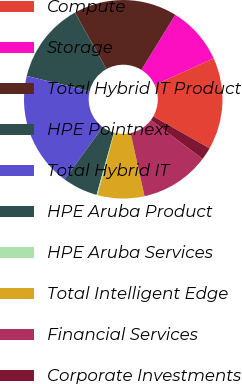Convert chart to OTSL. <chart><loc_0><loc_0><loc_500><loc_500><pie_chart><fcel>Compute<fcel>Storage<fcel>Total Hybrid IT Product<fcel>HPE Pointnext<fcel>Total Hybrid IT<fcel>HPE Aruba Product<fcel>HPE Aruba Services<fcel>Total Intelligent Edge<fcel>Financial Services<fcel>Corporate Investments<nl><fcel>15.0%<fcel>9.44%<fcel>16.86%<fcel>13.15%<fcel>18.71%<fcel>5.74%<fcel>0.18%<fcel>7.59%<fcel>11.3%<fcel>2.03%<nl></chart> 